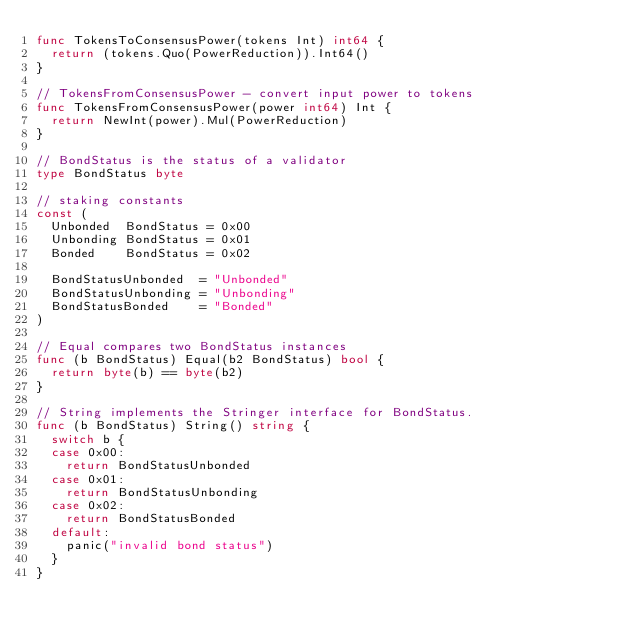<code> <loc_0><loc_0><loc_500><loc_500><_Go_>func TokensToConsensusPower(tokens Int) int64 {
	return (tokens.Quo(PowerReduction)).Int64()
}

// TokensFromConsensusPower - convert input power to tokens
func TokensFromConsensusPower(power int64) Int {
	return NewInt(power).Mul(PowerReduction)
}

// BondStatus is the status of a validator
type BondStatus byte

// staking constants
const (
	Unbonded  BondStatus = 0x00
	Unbonding BondStatus = 0x01
	Bonded    BondStatus = 0x02

	BondStatusUnbonded  = "Unbonded"
	BondStatusUnbonding = "Unbonding"
	BondStatusBonded    = "Bonded"
)

// Equal compares two BondStatus instances
func (b BondStatus) Equal(b2 BondStatus) bool {
	return byte(b) == byte(b2)
}

// String implements the Stringer interface for BondStatus.
func (b BondStatus) String() string {
	switch b {
	case 0x00:
		return BondStatusUnbonded
	case 0x01:
		return BondStatusUnbonding
	case 0x02:
		return BondStatusBonded
	default:
		panic("invalid bond status")
	}
}
</code> 